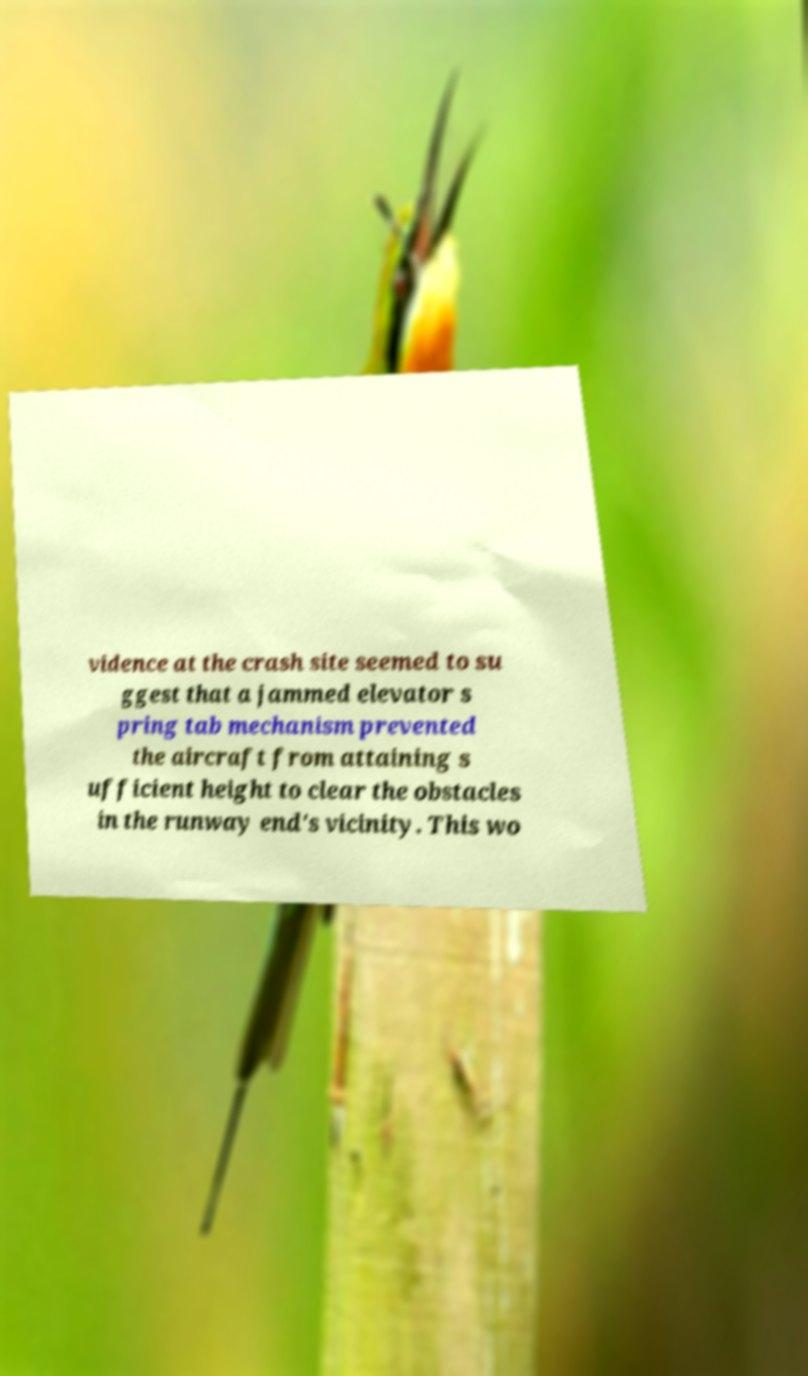Could you assist in decoding the text presented in this image and type it out clearly? vidence at the crash site seemed to su ggest that a jammed elevator s pring tab mechanism prevented the aircraft from attaining s ufficient height to clear the obstacles in the runway end's vicinity. This wo 